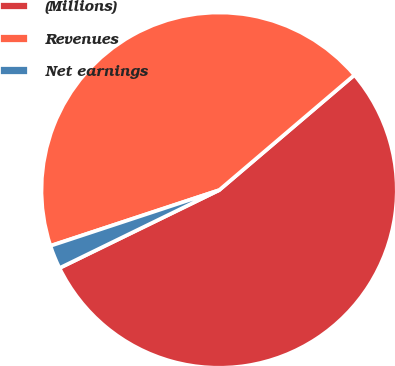Convert chart. <chart><loc_0><loc_0><loc_500><loc_500><pie_chart><fcel>(Millions)<fcel>Revenues<fcel>Net earnings<nl><fcel>54.0%<fcel>43.85%<fcel>2.15%<nl></chart> 